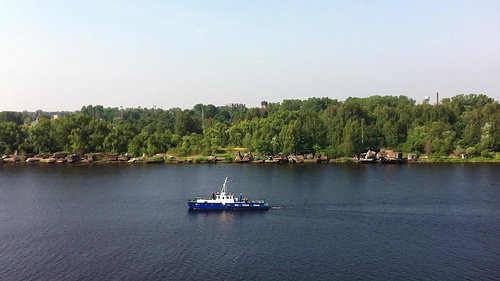Please provide the bounding box coordinate of the region this sentence describes: Blue and white boat. A striking blue and white boat can be seen between coordinates [0.34, 0.56, 0.56, 0.67], likely used for leisure or small-scale fishing, resting calmly on the river. 